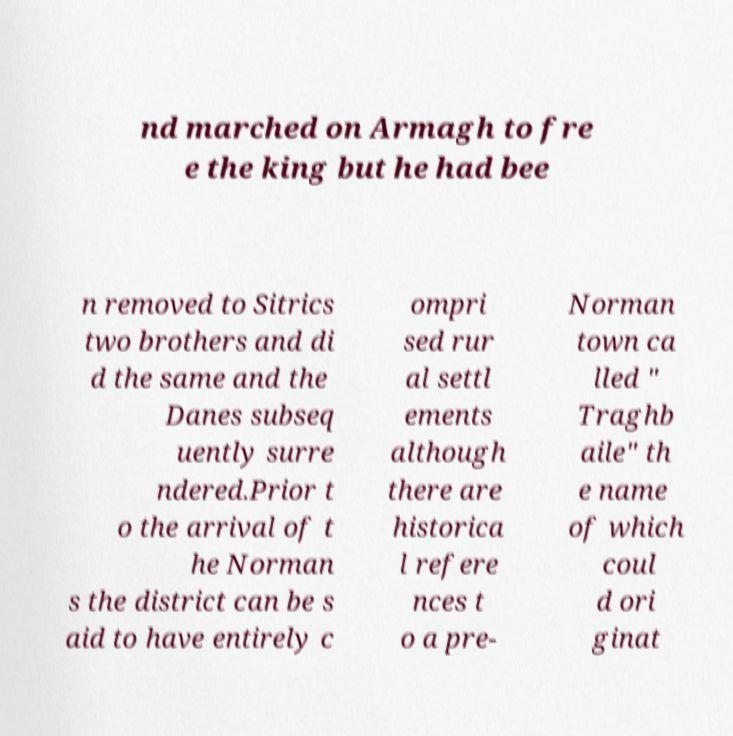For documentation purposes, I need the text within this image transcribed. Could you provide that? nd marched on Armagh to fre e the king but he had bee n removed to Sitrics two brothers and di d the same and the Danes subseq uently surre ndered.Prior t o the arrival of t he Norman s the district can be s aid to have entirely c ompri sed rur al settl ements although there are historica l refere nces t o a pre- Norman town ca lled " Traghb aile" th e name of which coul d ori ginat 